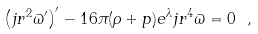<formula> <loc_0><loc_0><loc_500><loc_500>\left ( j r ^ { 2 } \varpi ^ { \prime } \right ) ^ { \prime } - 1 6 \pi ( \rho + p ) e ^ { \lambda } j r ^ { 4 } \varpi = 0 \ ,</formula> 